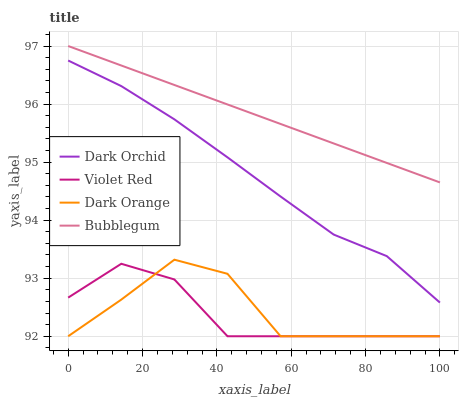Does Violet Red have the minimum area under the curve?
Answer yes or no. Yes. Does Bubblegum have the maximum area under the curve?
Answer yes or no. Yes. Does Bubblegum have the minimum area under the curve?
Answer yes or no. No. Does Violet Red have the maximum area under the curve?
Answer yes or no. No. Is Bubblegum the smoothest?
Answer yes or no. Yes. Is Dark Orange the roughest?
Answer yes or no. Yes. Is Violet Red the smoothest?
Answer yes or no. No. Is Violet Red the roughest?
Answer yes or no. No. Does Dark Orange have the lowest value?
Answer yes or no. Yes. Does Bubblegum have the lowest value?
Answer yes or no. No. Does Bubblegum have the highest value?
Answer yes or no. Yes. Does Violet Red have the highest value?
Answer yes or no. No. Is Violet Red less than Dark Orchid?
Answer yes or no. Yes. Is Bubblegum greater than Violet Red?
Answer yes or no. Yes. Does Dark Orange intersect Violet Red?
Answer yes or no. Yes. Is Dark Orange less than Violet Red?
Answer yes or no. No. Is Dark Orange greater than Violet Red?
Answer yes or no. No. Does Violet Red intersect Dark Orchid?
Answer yes or no. No. 